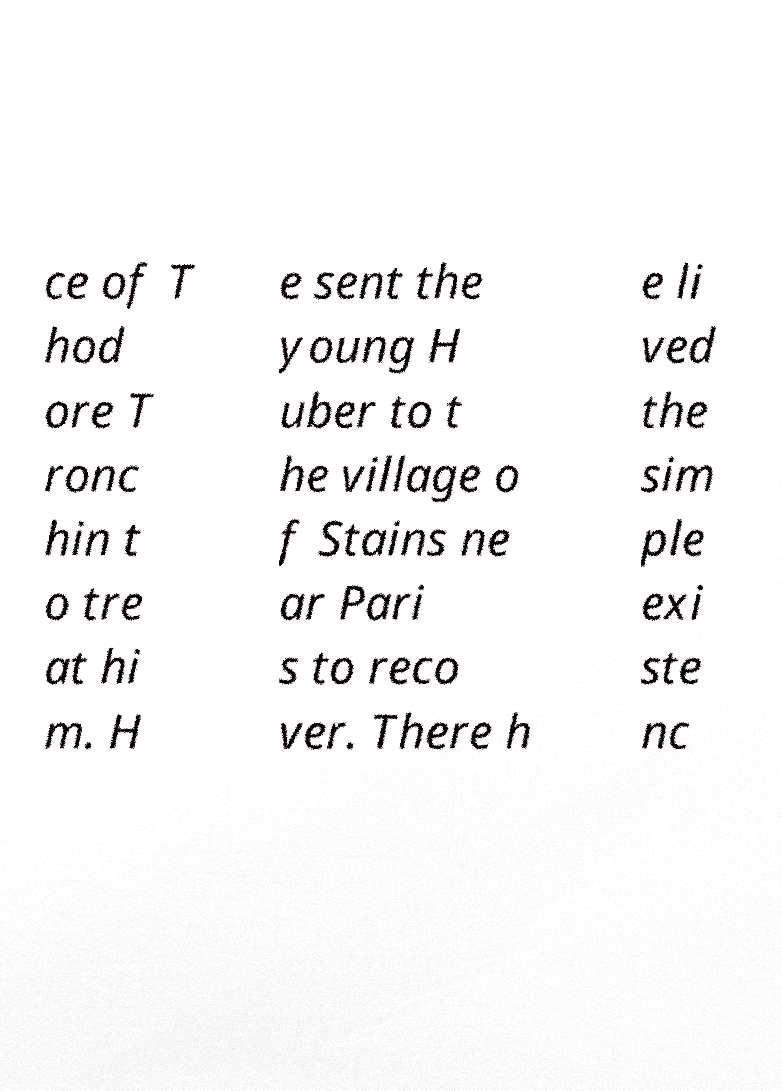Can you read and provide the text displayed in the image?This photo seems to have some interesting text. Can you extract and type it out for me? ce of T hod ore T ronc hin t o tre at hi m. H e sent the young H uber to t he village o f Stains ne ar Pari s to reco ver. There h e li ved the sim ple exi ste nc 